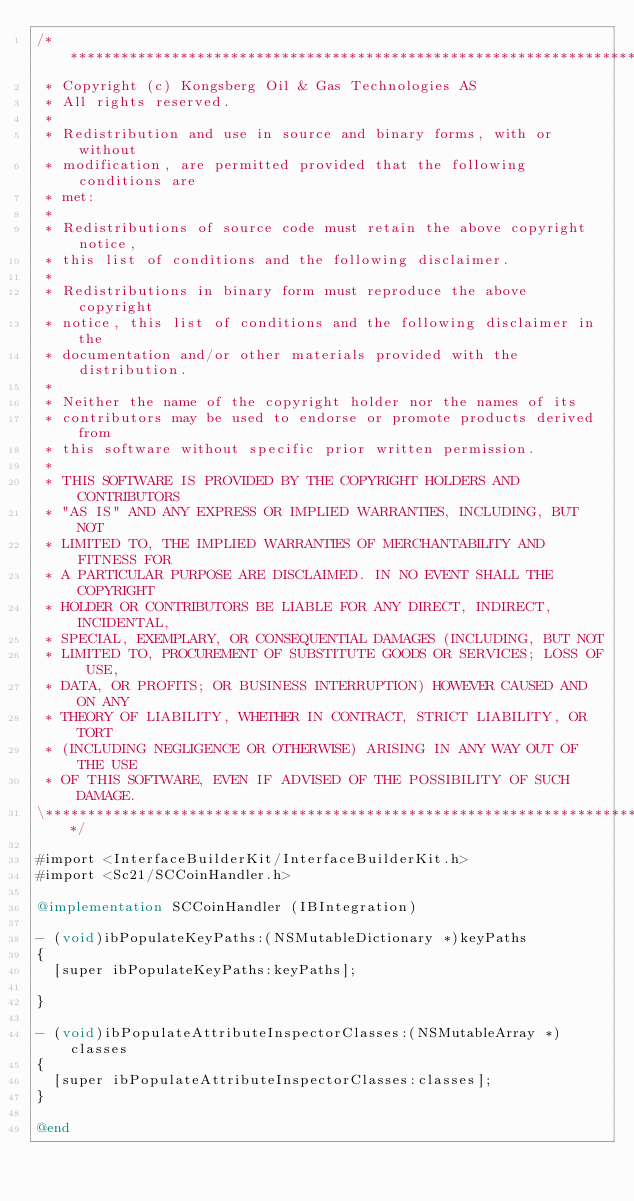Convert code to text. <code><loc_0><loc_0><loc_500><loc_500><_ObjectiveC_>/**************************************************************************\
 * Copyright (c) Kongsberg Oil & Gas Technologies AS
 * All rights reserved.
 * 
 * Redistribution and use in source and binary forms, with or without
 * modification, are permitted provided that the following conditions are
 * met:
 * 
 * Redistributions of source code must retain the above copyright notice,
 * this list of conditions and the following disclaimer.
 * 
 * Redistributions in binary form must reproduce the above copyright
 * notice, this list of conditions and the following disclaimer in the
 * documentation and/or other materials provided with the distribution.
 * 
 * Neither the name of the copyright holder nor the names of its
 * contributors may be used to endorse or promote products derived from
 * this software without specific prior written permission.
 * 
 * THIS SOFTWARE IS PROVIDED BY THE COPYRIGHT HOLDERS AND CONTRIBUTORS
 * "AS IS" AND ANY EXPRESS OR IMPLIED WARRANTIES, INCLUDING, BUT NOT
 * LIMITED TO, THE IMPLIED WARRANTIES OF MERCHANTABILITY AND FITNESS FOR
 * A PARTICULAR PURPOSE ARE DISCLAIMED. IN NO EVENT SHALL THE COPYRIGHT
 * HOLDER OR CONTRIBUTORS BE LIABLE FOR ANY DIRECT, INDIRECT, INCIDENTAL,
 * SPECIAL, EXEMPLARY, OR CONSEQUENTIAL DAMAGES (INCLUDING, BUT NOT
 * LIMITED TO, PROCUREMENT OF SUBSTITUTE GOODS OR SERVICES; LOSS OF USE,
 * DATA, OR PROFITS; OR BUSINESS INTERRUPTION) HOWEVER CAUSED AND ON ANY
 * THEORY OF LIABILITY, WHETHER IN CONTRACT, STRICT LIABILITY, OR TORT
 * (INCLUDING NEGLIGENCE OR OTHERWISE) ARISING IN ANY WAY OUT OF THE USE
 * OF THIS SOFTWARE, EVEN IF ADVISED OF THE POSSIBILITY OF SUCH DAMAGE.
\**************************************************************************/

#import <InterfaceBuilderKit/InterfaceBuilderKit.h>
#import <Sc21/SCCoinHandler.h>

@implementation SCCoinHandler (IBIntegration)

- (void)ibPopulateKeyPaths:(NSMutableDictionary *)keyPaths
{
  [super ibPopulateKeyPaths:keyPaths];
	
}

- (void)ibPopulateAttributeInspectorClasses:(NSMutableArray *)classes
{
  [super ibPopulateAttributeInspectorClasses:classes];
}

@end
</code> 